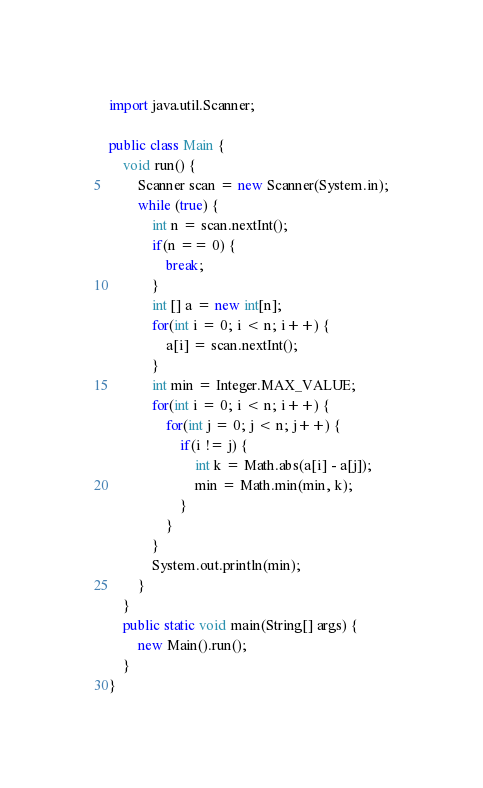Convert code to text. <code><loc_0><loc_0><loc_500><loc_500><_Java_>import java.util.Scanner;

public class Main {
	void run() {
		Scanner scan = new Scanner(System.in);
		while (true) {
			int n = scan.nextInt();
			if(n == 0) {
				break;
			}
			int [] a = new int[n];
			for(int i = 0; i < n; i++) {
				a[i] = scan.nextInt();
			}
			int min = Integer.MAX_VALUE;
			for(int i = 0; i < n; i++) {
				for(int j = 0; j < n; j++) {
					if(i != j) {
						int k = Math.abs(a[i] - a[j]);
						min = Math.min(min, k);
					}
				}
			}
			System.out.println(min);
		}
	}
	public static void main(String[] args) {
		new Main().run();
	}
}</code> 